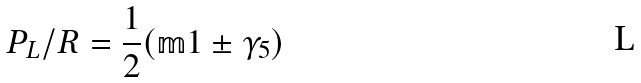<formula> <loc_0><loc_0><loc_500><loc_500>P _ { L } / R = \frac { 1 } { 2 } ( \mathbb { m } 1 \pm \gamma _ { 5 } )</formula> 